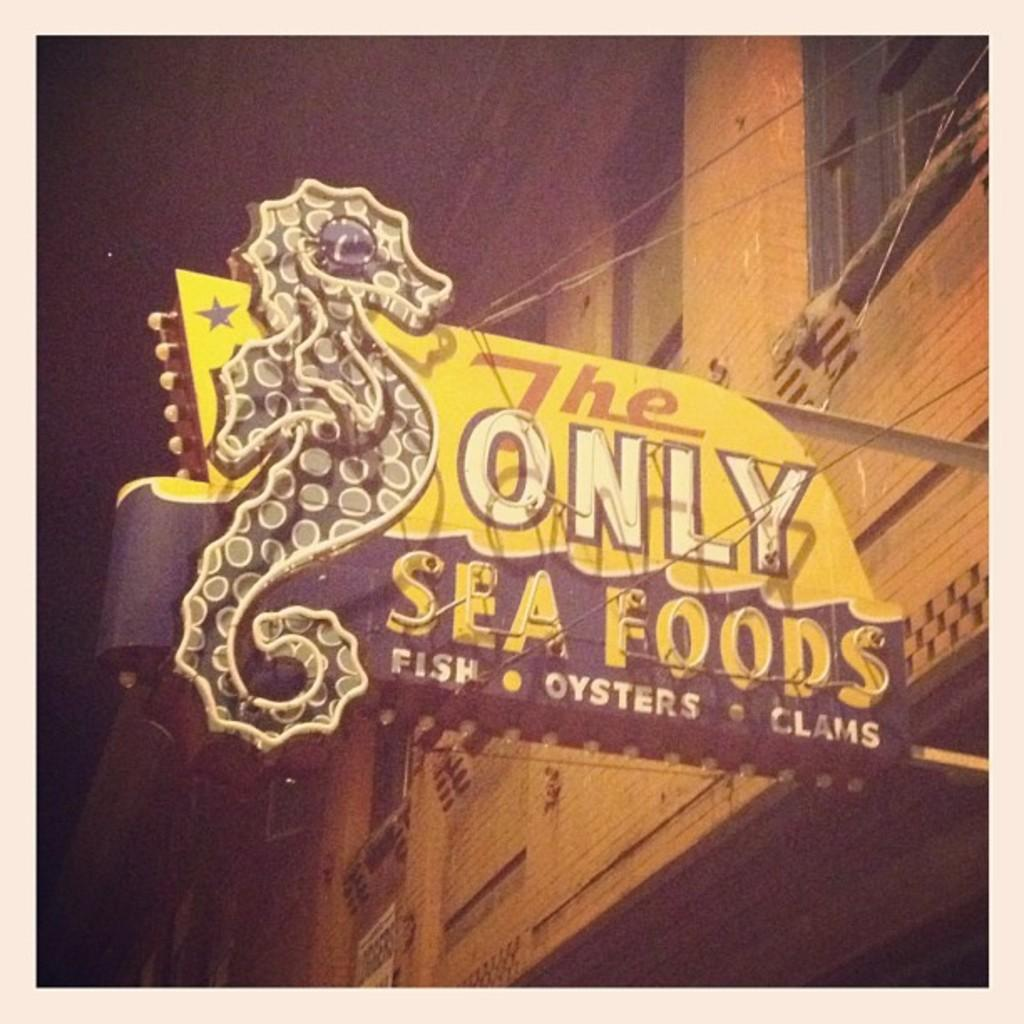What is the main subject of the image? The main subject of the image is a building wall. What features can be seen on the building wall? The building wall has windows and a board attached to it. What is written on the board? The board mentions "only sea foods." What type of behavior can be observed in the image? There is no behavior depicted in the image; it features a building wall with windows and a board. Is there a watch visible in the image? There is no watch present in the image. 